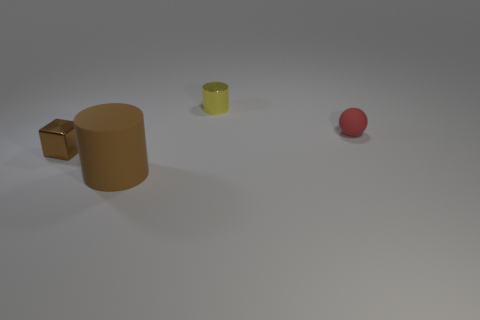What is the color of the rubber thing that is the same shape as the yellow shiny object?
Ensure brevity in your answer.  Brown. What is the thing that is both in front of the tiny red ball and to the right of the brown shiny cube made of?
Offer a very short reply. Rubber. The other yellow metallic thing that is the same shape as the big thing is what size?
Provide a short and direct response. Small. Are there the same number of small metallic objects in front of the tiny red ball and red rubber balls that are on the right side of the brown metallic thing?
Your answer should be compact. Yes. There is a cylinder that is in front of the small object to the right of the yellow cylinder; what is it made of?
Your answer should be very brief. Rubber. Are there more small brown objects on the left side of the large cylinder than big blue things?
Ensure brevity in your answer.  Yes. What number of other things are the same color as the matte sphere?
Ensure brevity in your answer.  0. There is a yellow metallic object that is the same size as the rubber ball; what is its shape?
Your response must be concise. Cylinder. How many small yellow metal objects are on the left side of the cylinder that is behind the sphere behind the cube?
Provide a short and direct response. 0. How many matte things are red things or large brown things?
Give a very brief answer. 2. 